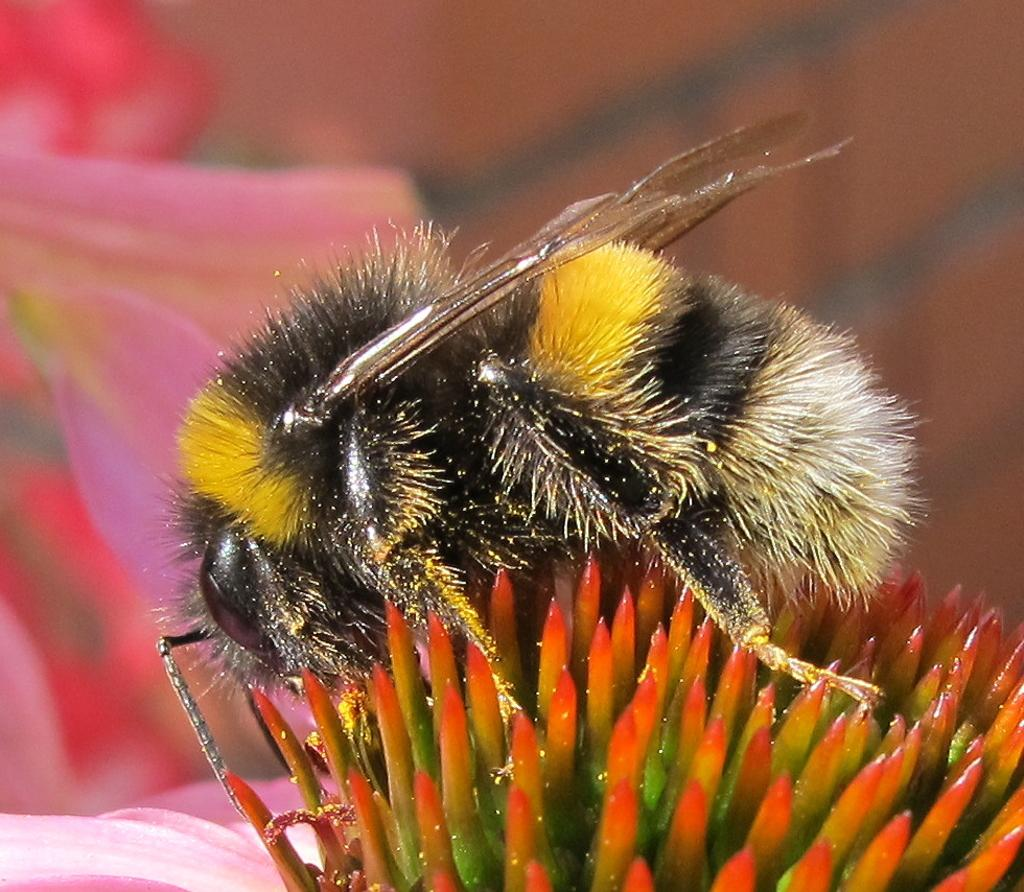What is the main subject in the foreground of the image? There is an insect on a flower in the foreground of the image. What type of flowers can be seen in the background of the image? There are pink flowers in the background of the image. Can you describe any specific area of the image? The top right portion of the image is blurred. What is the value of the sister's appliance in the image? There is no sister or appliance present in the image. 